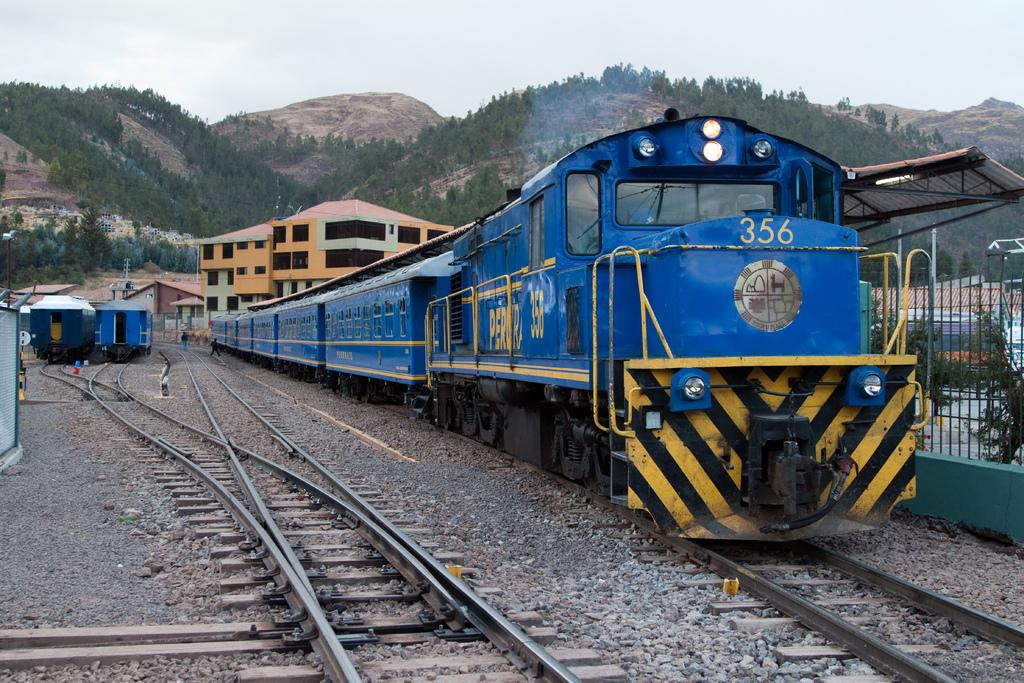<image>
Relay a brief, clear account of the picture shown. A blue locomotive number 356 is leaving a train station. 